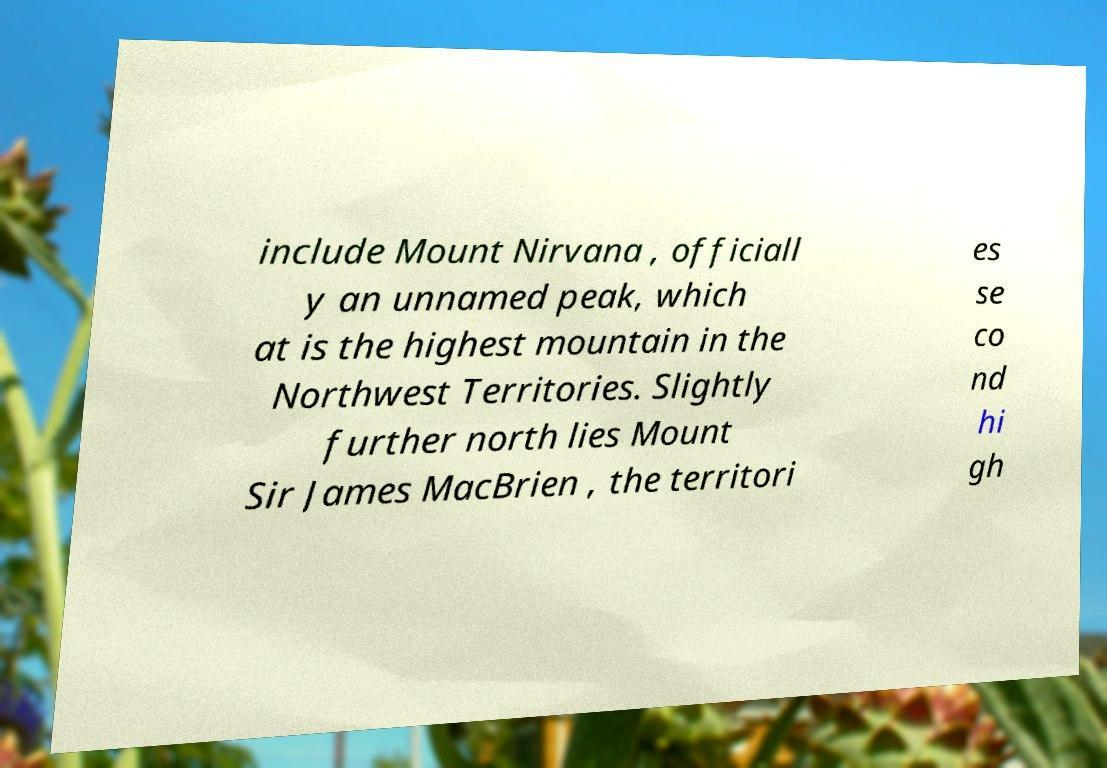Can you accurately transcribe the text from the provided image for me? include Mount Nirvana , officiall y an unnamed peak, which at is the highest mountain in the Northwest Territories. Slightly further north lies Mount Sir James MacBrien , the territori es se co nd hi gh 